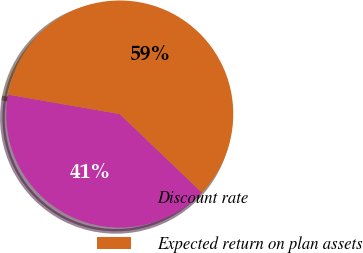<chart> <loc_0><loc_0><loc_500><loc_500><pie_chart><fcel>Discount rate<fcel>Expected return on plan assets<nl><fcel>40.6%<fcel>59.4%<nl></chart> 